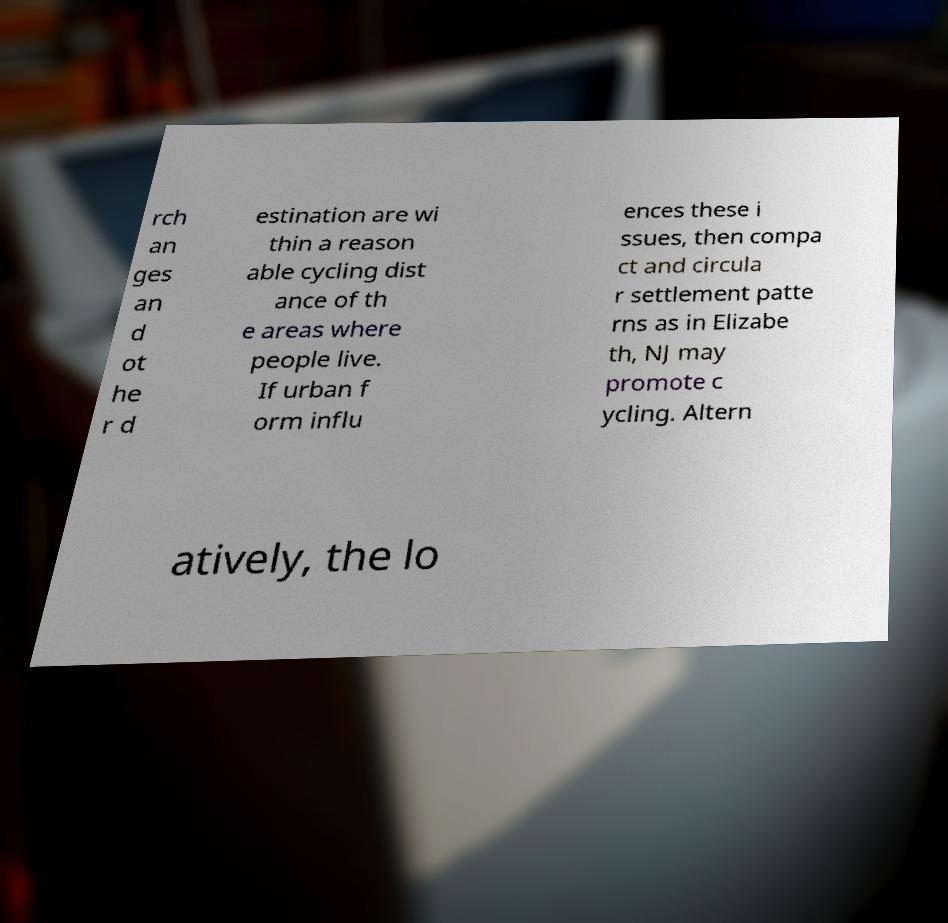What messages or text are displayed in this image? I need them in a readable, typed format. rch an ges an d ot he r d estination are wi thin a reason able cycling dist ance of th e areas where people live. If urban f orm influ ences these i ssues, then compa ct and circula r settlement patte rns as in Elizabe th, NJ may promote c ycling. Altern atively, the lo 